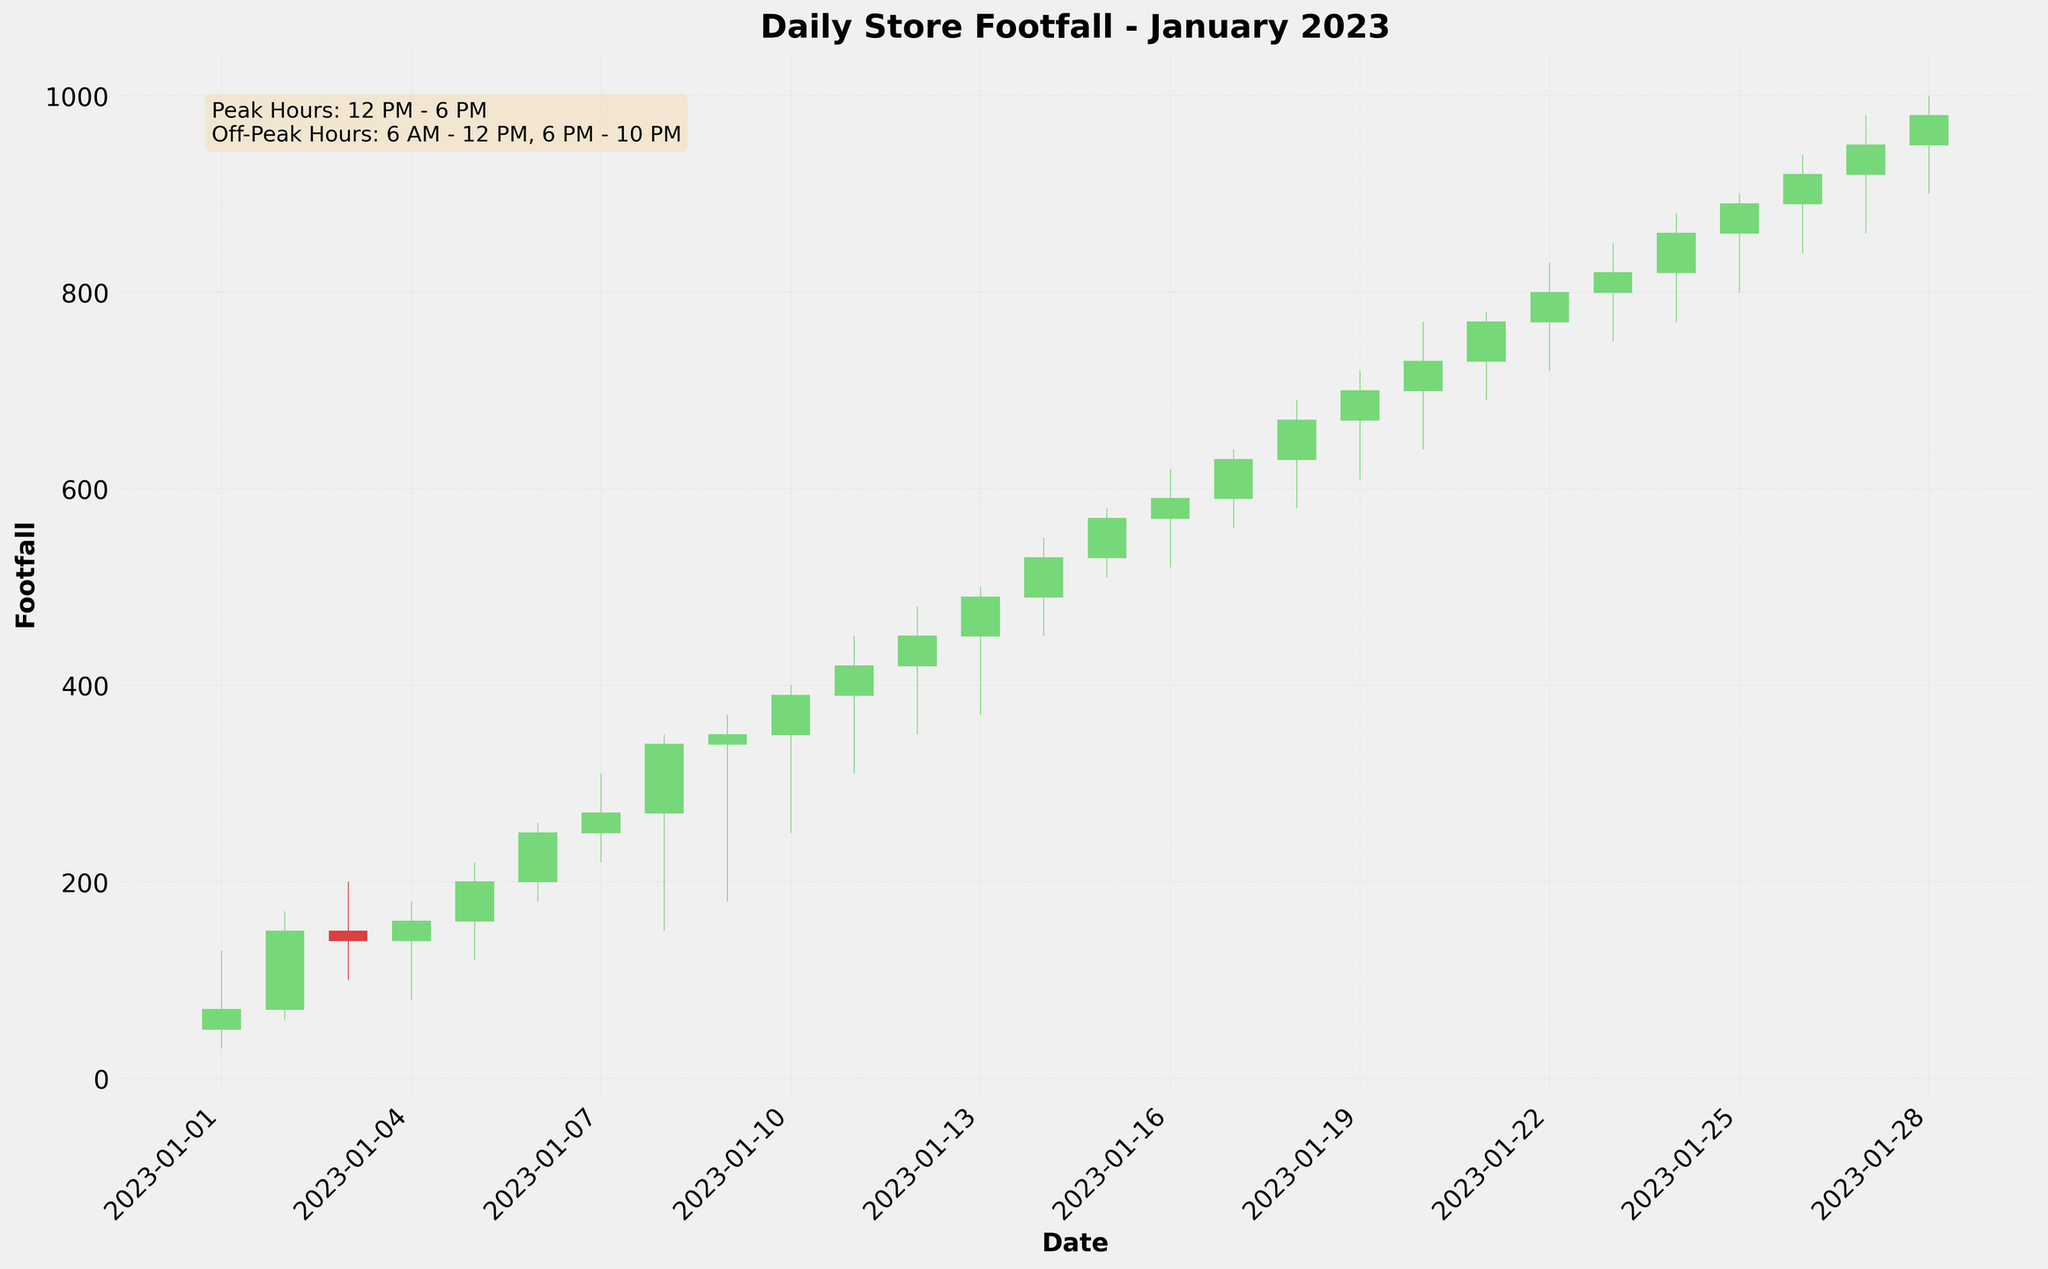What is the title of the plot? The title of the plot is at the top center of the figure, which reads "Daily Store Footfall - January 2023."
Answer: Daily Store Footfall - January 2023 What are the axes labels in the plot? The axes labels are shown along the x-axis and y-axis of the figure. The x-axis is labeled "Date," and the y-axis is labeled "Footfall."
Answer: Date, Footfall How many major ticks are there on the x-axis? The x-axis has major ticks labeled at intervals of three days. These are displayed beneath the x-axis.
Answer: 10 Which color represents an increase in footfall for the day? In the candlestick plot, a green-colored candlestick represents an increase in footfall for the day. This can be seen by identifying the days where the close value is higher than the open value.
Answer: Green How many days in January 2023 had a higher closing footfall than the opening footfall? We need to count the number of green candlestick days where the closing value is higher than the opening value. There are 20 such days.
Answer: 20 On which day was the lowest footfall recorded and what was the value? The lowest footfall is identified by the lowest point of any candlestick across the plot. This occurred on January 1st, with a low value of 30.
Answer: January 1, 30 What is the average closing footfall for the first week of January 2023? Calculate the average of the closing footfall values for January 1 to January 7. (70 + 150 + 140 + 160 + 200 + 250 + 270) / 7 = 1240 / 7 = 177.14
Answer: 177.14 Compare the highest footfall on January 6th with that on January 13th. Which day had a higher footfall? January 6th had a high of 260 and January 13th had a high of 500. Since 500 is greater than 260, January 13th had a higher footfall.
Answer: January 13 What can be inferred about footfall trends between January 1st and January 10th? By observing the candlesticks from January 1st to January 10th, the footfall generally increases consistently, with some minor decreases. We see larger candlesticks and the closing values generally rise, indicating an upward trend.
Answer: Increasing Trend What hours are considered off-peak according to the text box in the plot? The text box at the top left of the plot mentions that off-peak hours are from 6 AM to 12 PM and 6 PM to 10 PM.
Answer: 6 AM - 12 PM, 6 PM - 10 PM 